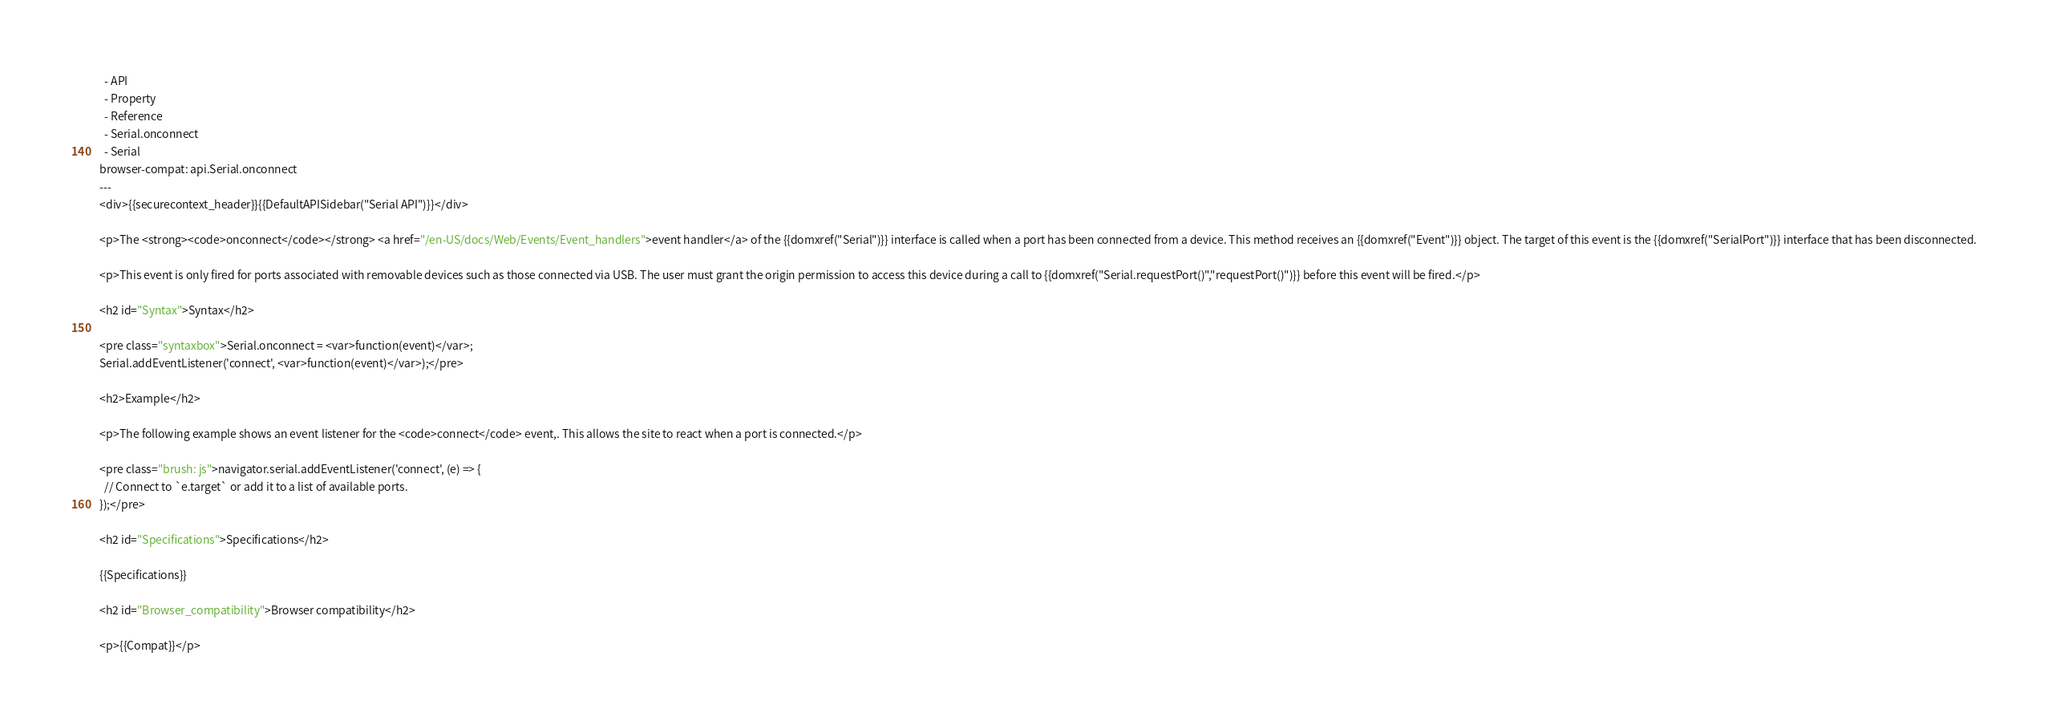Convert code to text. <code><loc_0><loc_0><loc_500><loc_500><_HTML_>  - API
  - Property
  - Reference
  - Serial.onconnect
  - Serial
browser-compat: api.Serial.onconnect
---
<div>{{securecontext_header}}{{DefaultAPISidebar("Serial API")}}</div>

<p>The <strong><code>onconnect</code></strong> <a href="/en-US/docs/Web/Events/Event_handlers">event handler</a> of the {{domxref("Serial")}} interface is called when a port has been connected from a device. This method receives an {{domxref("Event")}} object. The target of this event is the {{domxref("SerialPort")}} interface that has been disconnected.

<p>This event is only fired for ports associated with removable devices such as those connected via USB. The user must grant the origin permission to access this device during a call to {{domxref("Serial.requestPort()","requestPort()")}} before this event will be fired.</p>

<h2 id="Syntax">Syntax</h2>

<pre class="syntaxbox">Serial.onconnect = <var>function(event)</var>;
Serial.addEventListener('connect', <var>function(event)</var>);</pre>

<h2>Example</h2>

<p>The following example shows an event listener for the <code>connect</code> event,. This allows the site to react when a port is connected.</p>

<pre class="brush: js">navigator.serial.addEventListener('connect', (e) => {
  // Connect to `e.target` or add it to a list of available ports.
});</pre>

<h2 id="Specifications">Specifications</h2>

{{Specifications}}

<h2 id="Browser_compatibility">Browser compatibility</h2>

<p>{{Compat}}</p>
</code> 